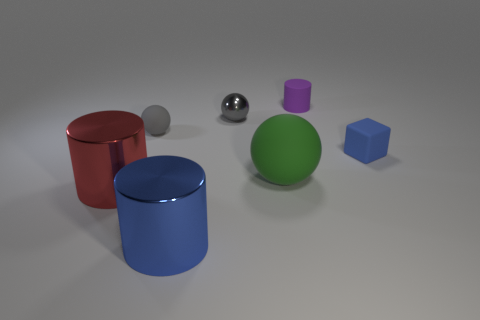Subtract all big balls. How many balls are left? 2 Subtract all blue cylinders. How many cylinders are left? 2 Subtract all spheres. How many objects are left? 4 Subtract 2 balls. How many balls are left? 1 Subtract all cylinders. Subtract all large metal cylinders. How many objects are left? 2 Add 2 large blue metal things. How many large blue metal things are left? 3 Add 6 tiny cyan metallic cylinders. How many tiny cyan metallic cylinders exist? 6 Add 2 large green things. How many objects exist? 9 Subtract 1 red cylinders. How many objects are left? 6 Subtract all yellow balls. Subtract all yellow cubes. How many balls are left? 3 